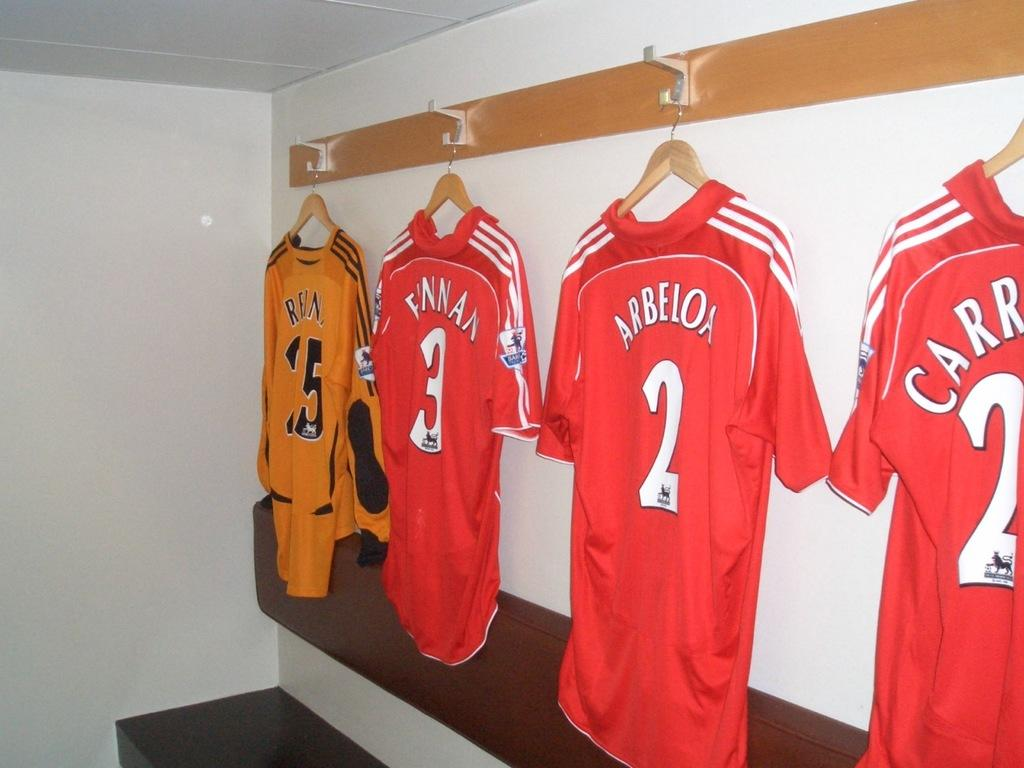<image>
Write a terse but informative summary of the picture. Three red jerseys, one with the name Arbeloa, and one gold jersey hang on hooks. 